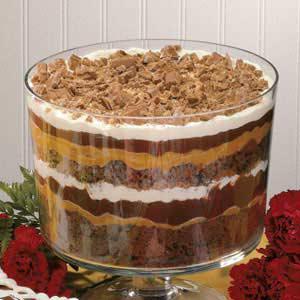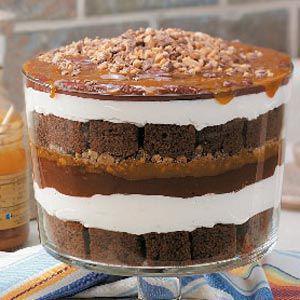The first image is the image on the left, the second image is the image on the right. Analyze the images presented: Is the assertion "A dessert with a thick bottom chocolate layer and chocolate garnish on top is served in a non-footed glass." valid? Answer yes or no. No. The first image is the image on the left, the second image is the image on the right. Assess this claim about the two images: "Two large layered desserts made with chocolate and creamy layers and topped with a garnish are in clear glass bowls, at least one of them footed.". Correct or not? Answer yes or no. Yes. 